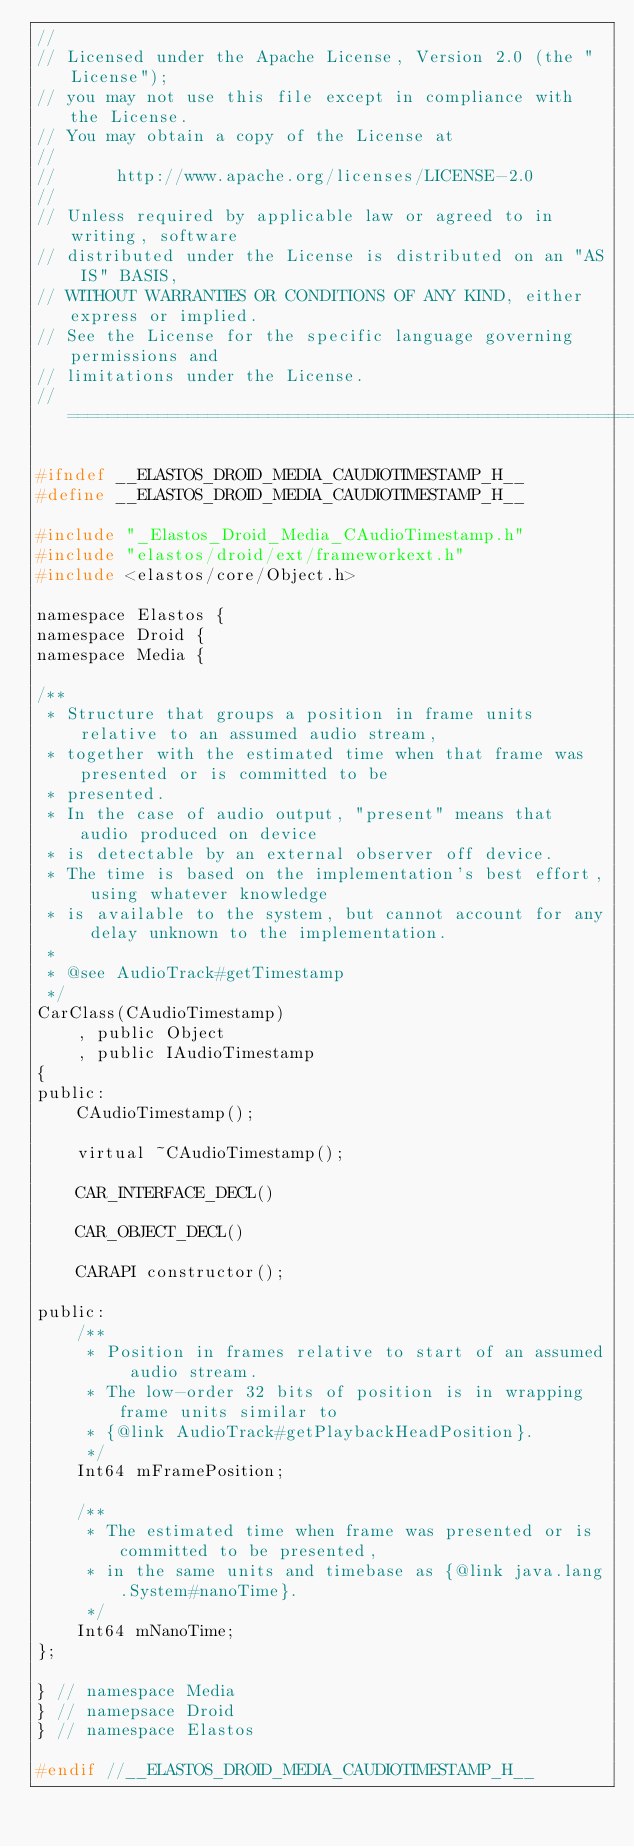<code> <loc_0><loc_0><loc_500><loc_500><_C_>//
// Licensed under the Apache License, Version 2.0 (the "License");
// you may not use this file except in compliance with the License.
// You may obtain a copy of the License at
//
//      http://www.apache.org/licenses/LICENSE-2.0
//
// Unless required by applicable law or agreed to in writing, software
// distributed under the License is distributed on an "AS IS" BASIS,
// WITHOUT WARRANTIES OR CONDITIONS OF ANY KIND, either express or implied.
// See the License for the specific language governing permissions and
// limitations under the License.
//=========================================================================

#ifndef __ELASTOS_DROID_MEDIA_CAUDIOTIMESTAMP_H__
#define __ELASTOS_DROID_MEDIA_CAUDIOTIMESTAMP_H__

#include "_Elastos_Droid_Media_CAudioTimestamp.h"
#include "elastos/droid/ext/frameworkext.h"
#include <elastos/core/Object.h>

namespace Elastos {
namespace Droid {
namespace Media {

/**
 * Structure that groups a position in frame units relative to an assumed audio stream,
 * together with the estimated time when that frame was presented or is committed to be
 * presented.
 * In the case of audio output, "present" means that audio produced on device
 * is detectable by an external observer off device.
 * The time is based on the implementation's best effort, using whatever knowledge
 * is available to the system, but cannot account for any delay unknown to the implementation.
 *
 * @see AudioTrack#getTimestamp
 */
CarClass(CAudioTimestamp)
    , public Object
    , public IAudioTimestamp
{
public:
    CAudioTimestamp();

    virtual ~CAudioTimestamp();

    CAR_INTERFACE_DECL()

    CAR_OBJECT_DECL()

    CARAPI constructor();

public:
    /**
     * Position in frames relative to start of an assumed audio stream.
     * The low-order 32 bits of position is in wrapping frame units similar to
     * {@link AudioTrack#getPlaybackHeadPosition}.
     */
    Int64 mFramePosition;

    /**
     * The estimated time when frame was presented or is committed to be presented,
     * in the same units and timebase as {@link java.lang.System#nanoTime}.
     */
    Int64 mNanoTime;
};

} // namespace Media
} // namepsace Droid
} // namespace Elastos

#endif //__ELASTOS_DROID_MEDIA_CAUDIOTIMESTAMP_H__
</code> 